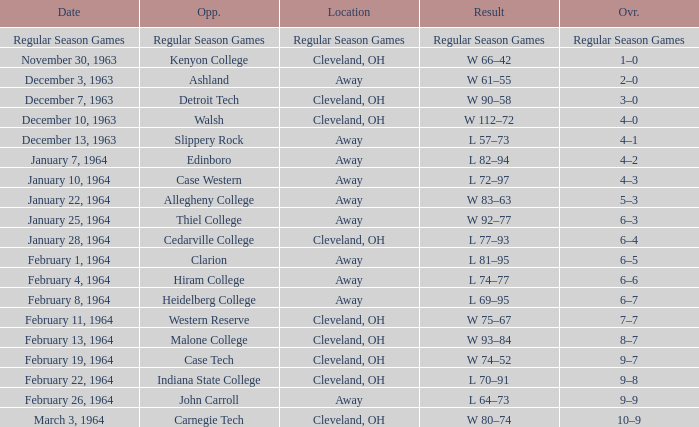What is the Overall with a Date that is february 4, 1964? 6–6. 